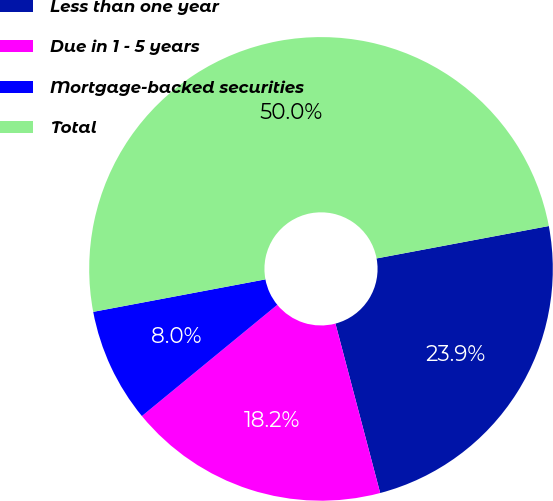Convert chart to OTSL. <chart><loc_0><loc_0><loc_500><loc_500><pie_chart><fcel>Less than one year<fcel>Due in 1 - 5 years<fcel>Mortgage-backed securities<fcel>Total<nl><fcel>23.85%<fcel>18.16%<fcel>7.98%<fcel>50.0%<nl></chart> 